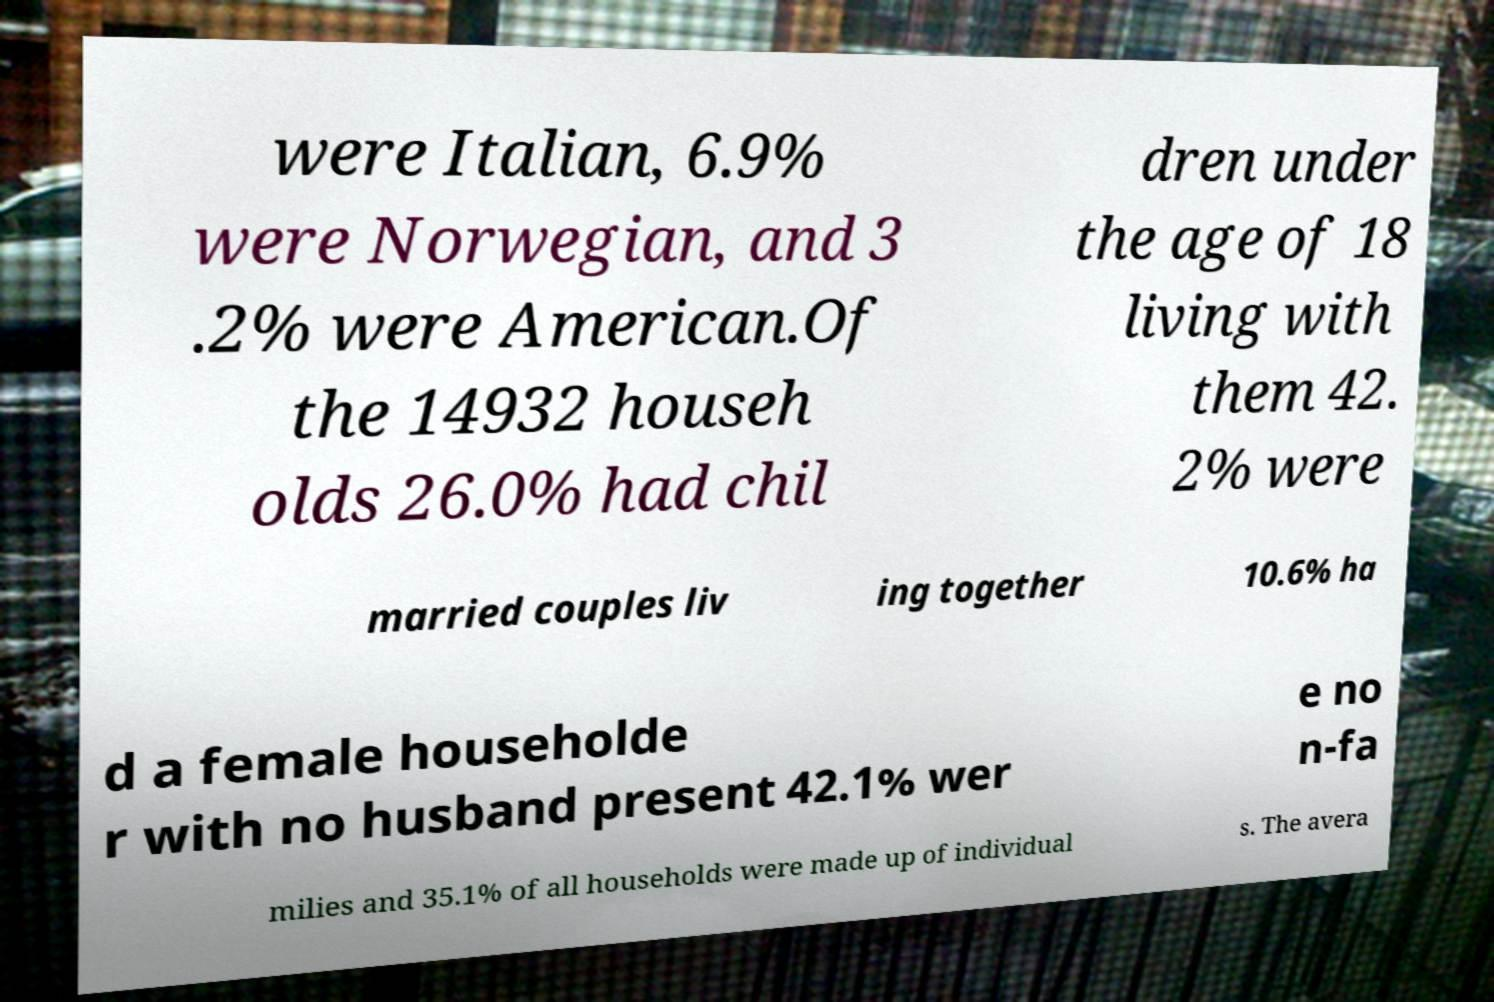What messages or text are displayed in this image? I need them in a readable, typed format. were Italian, 6.9% were Norwegian, and 3 .2% were American.Of the 14932 househ olds 26.0% had chil dren under the age of 18 living with them 42. 2% were married couples liv ing together 10.6% ha d a female householde r with no husband present 42.1% wer e no n-fa milies and 35.1% of all households were made up of individual s. The avera 